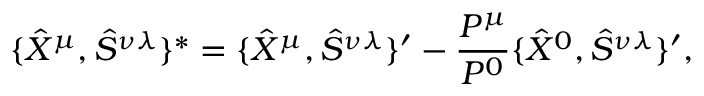<formula> <loc_0><loc_0><loc_500><loc_500>\{ \hat { X } ^ { \mu } , \hat { S } ^ { \nu \lambda } \} ^ { * } = \{ \hat { X } ^ { \mu } , \hat { S } ^ { \nu \lambda } \} ^ { \prime } - \frac { P ^ { \mu } } { P ^ { 0 } } \{ \hat { X } ^ { 0 } , \hat { S } ^ { \nu \lambda } \} ^ { \prime } ,</formula> 